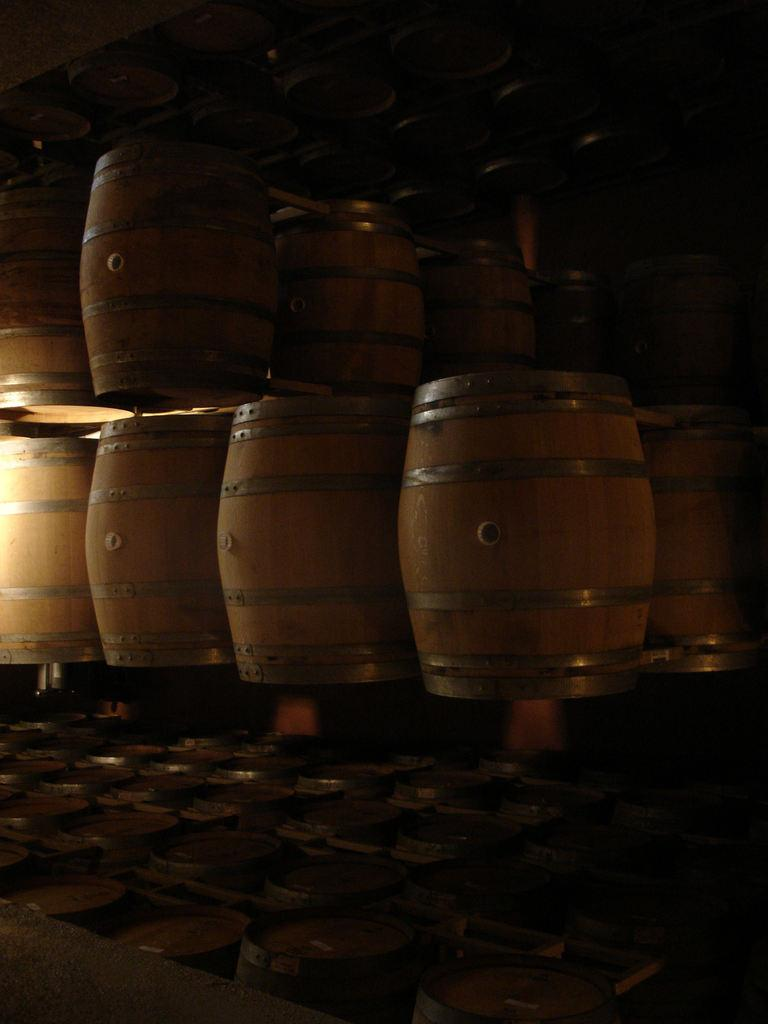What objects are present in the image? There are barrels in the image. How are the barrels arranged in the image? The barrels are placed in rows. Can you see any waves or a sofa in the image? No, there are no waves or sofa present in the image. Is there a crib visible in the image? No, there is no crib present in the image. 